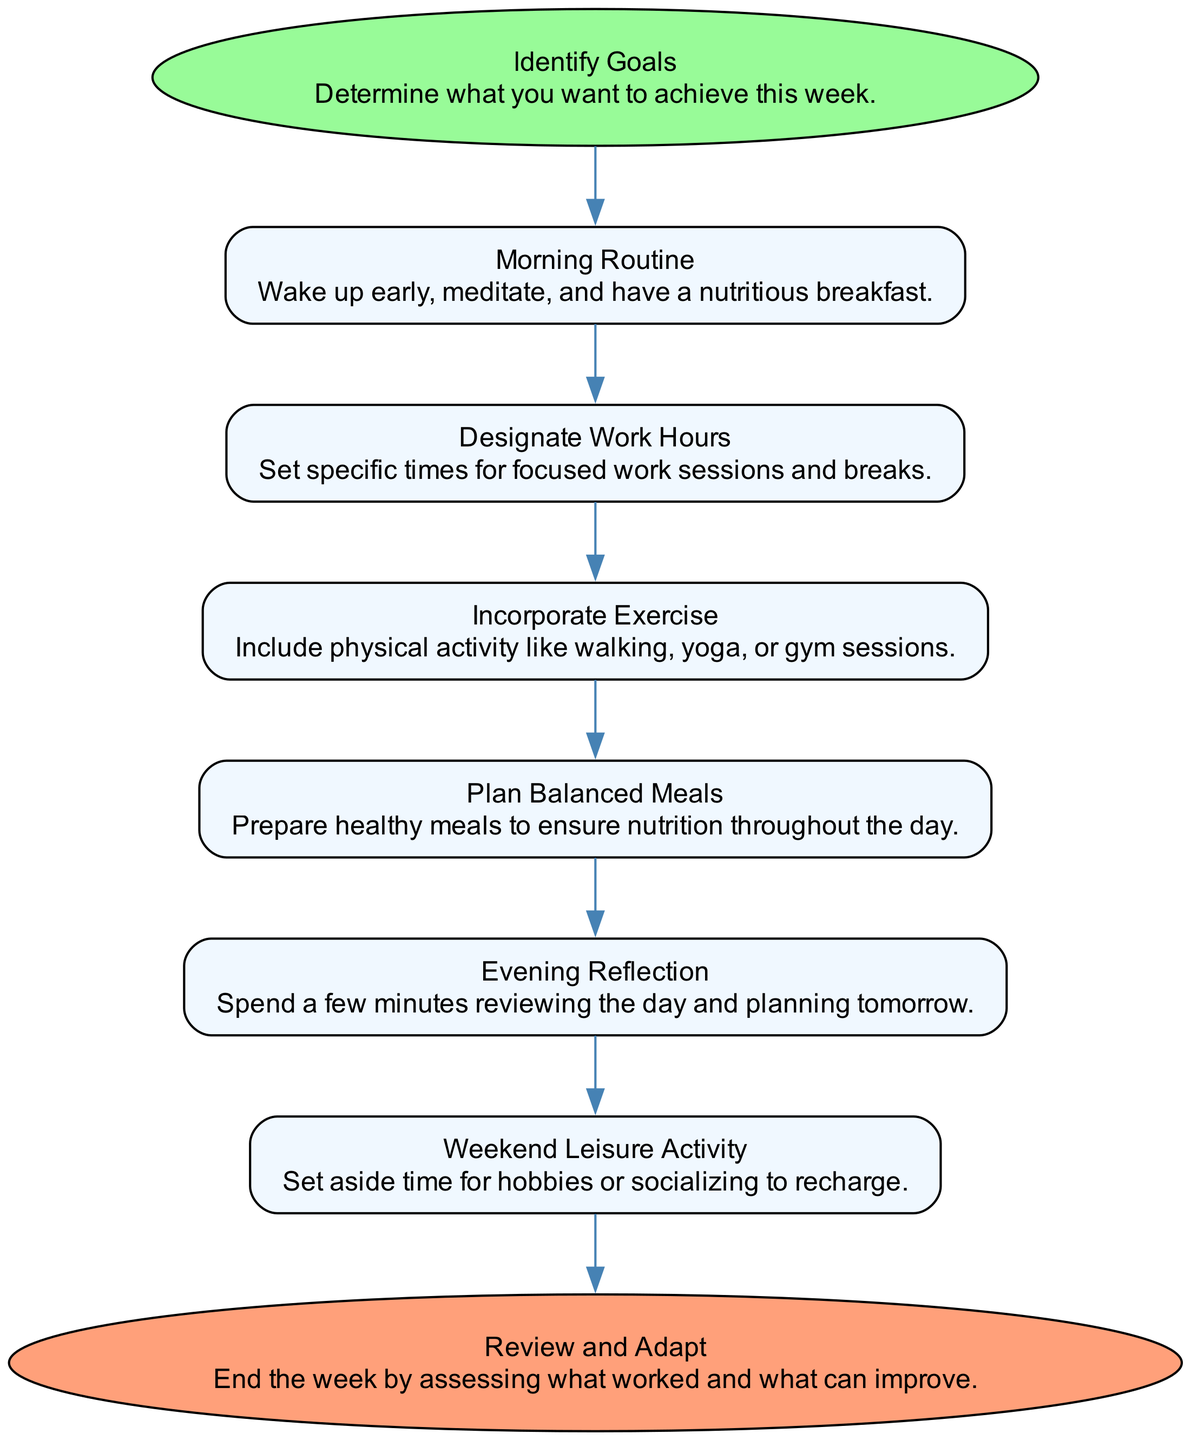What is the first step in the flow chart? The first step is "Identify Goals," which is represented at the top of the flow chart as the starting node.
Answer: Identify Goals How many nodes are present in the flow chart? The flow chart has a total of 8 nodes, which include each step from starting to the final review.
Answer: 8 What is the last activity mentioned in the flow chart? The last activity is "Review and Adapt," which is the end node of the flow chart indicating the conclusion of the weekly routine planning.
Answer: Review and Adapt Which activity follows "Designate Work Hours"? The activity that follows "Designate Work Hours" is "Incorporate Exercise," as represented by the arrow connecting the two nodes in the flow chart.
Answer: Incorporate Exercise What color is the starting node? The starting node "Identify Goals" is colored in pale green, indicating it is the first step of the process.
Answer: Pale green Which two activities are related to well-being in the flow chart? The activities related to well-being are "Incorporate Exercise" and "Evening Reflection," both of which focus on physical and mental health.
Answer: Incorporate Exercise, Evening Reflection How many steps are there between "Morning Routine" and "Review and Adapt"? There are five steps between "Morning Routine" and "Review and Adapt," tracing down through the flow from one to the other.
Answer: 5 What type of activities does the node "Weekend Leisure Activity" represent? The node "Weekend Leisure Activity" represents leisure or relaxation activities, providing a break from the weekly routine to recharge.
Answer: Leisure activities 